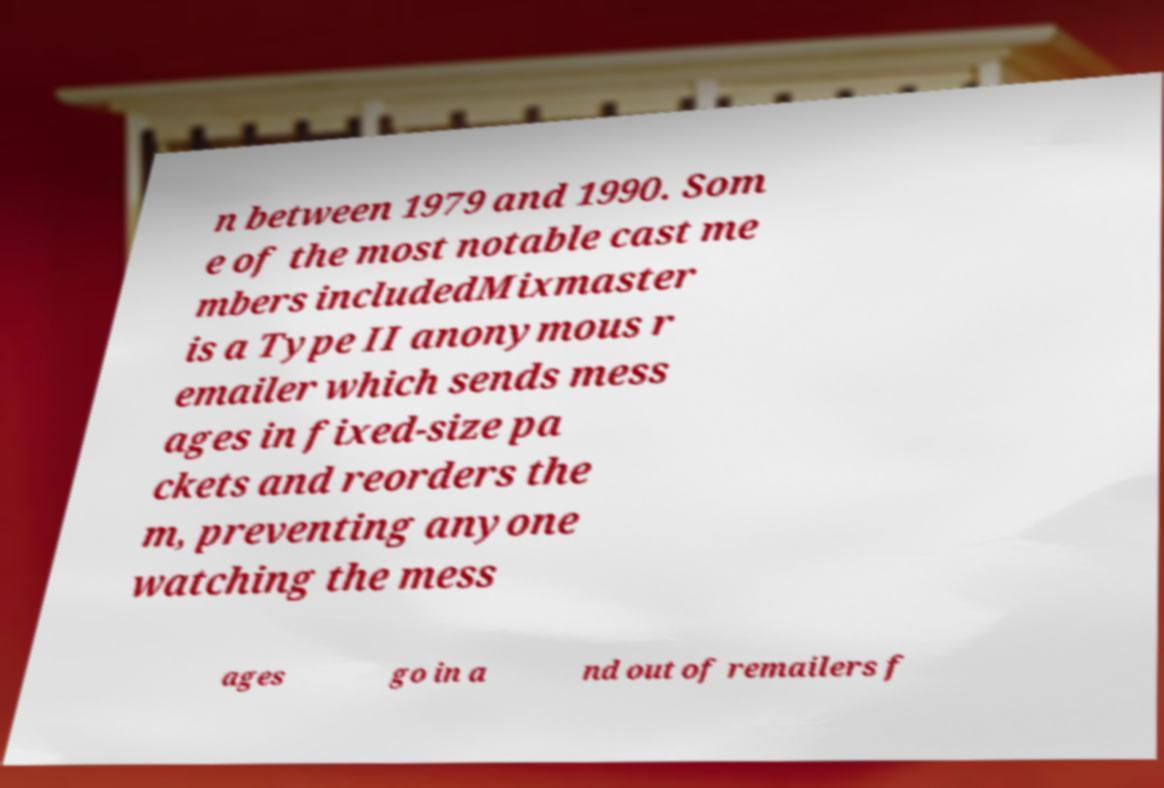Could you extract and type out the text from this image? n between 1979 and 1990. Som e of the most notable cast me mbers includedMixmaster is a Type II anonymous r emailer which sends mess ages in fixed-size pa ckets and reorders the m, preventing anyone watching the mess ages go in a nd out of remailers f 